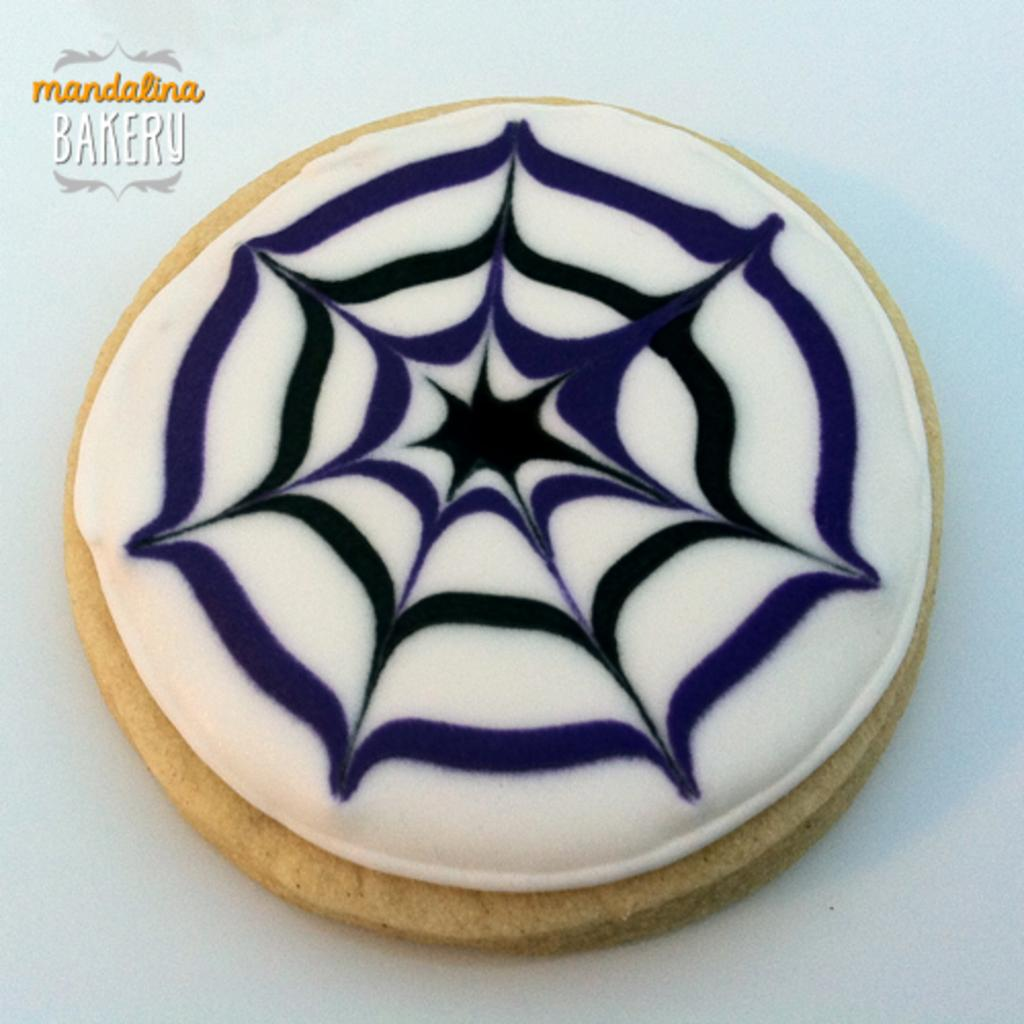What is the main subject of the image? There is a cake in the image. What color is the cream on the cake? The cake has white cream. Are there any other colors of cream on the cake? Yes, the cake has blue and black cream lines. What bakery is the cake from? The cake is from Mandolin Bakery. What hobbies does the cake enjoy in the image? The cake is an inanimate object and does not have hobbies. Can you see a match near the cake in the image? There is no match present in the image. 